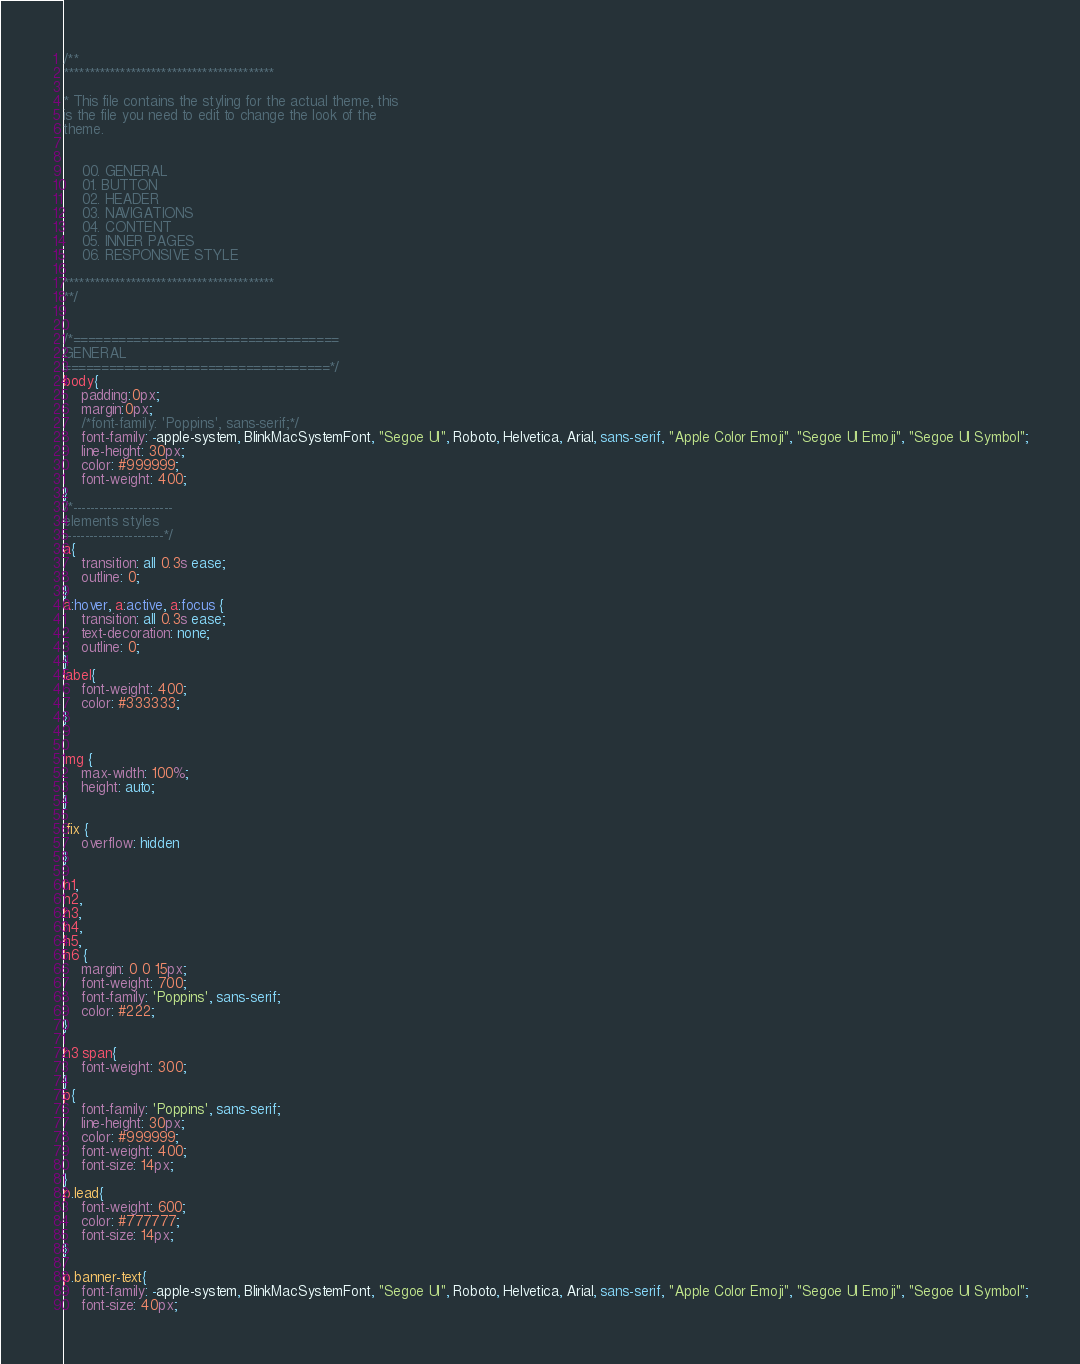Convert code to text. <code><loc_0><loc_0><loc_500><loc_500><_CSS_>/**
*****************************************

* This file contains the styling for the actual theme, this
is the file you need to edit to change the look of the
theme.


    00. GENERAL
    01. BUTTON
    02. HEADER
    03. NAVIGATIONS
    04. CONTENT
    05. INNER PAGES
    06. RESPONSIVE STYLE

*****************************************
**/


/*===================================
GENERAL
===================================*/
body{
    padding:0px; 
    margin:0px;
    /*font-family: 'Poppins', sans-serif;*/
    font-family: -apple-system, BlinkMacSystemFont, "Segoe UI", Roboto, Helvetica, Arial, sans-serif, "Apple Color Emoji", "Segoe UI Emoji", "Segoe UI Symbol";
    line-height: 30px;
    color: #999999;
    font-weight: 400;
}
/*-----------------------
elements styles
-----------------------*/
a{
    transition: all 0.3s ease;
    outline: 0;
}
a:hover, a:active, a:focus {
    transition: all 0.3s ease;
    text-decoration: none;
    outline: 0;
}
label{
    font-weight: 400;
    color: #333333;
}


img {
    max-width: 100%;
    height: auto;
}

.fix {
    overflow: hidden
}

h1,
h2,
h3,
h4,
h5,
h6 {
    margin: 0 0 15px;
    font-weight: 700;
    font-family: 'Poppins', sans-serif;
    color: #222;
}

h3 span{
    font-weight: 300;
}
p{
    font-family: 'Poppins', sans-serif;
    line-height: 30px;
    color: #999999;
    font-weight: 400;
    font-size: 14px;
}
p.lead{
    font-weight: 600;
    color: #777777;
    font-size: 14px;
}

p.banner-text{
    font-family: -apple-system, BlinkMacSystemFont, "Segoe UI", Roboto, Helvetica, Arial, sans-serif, "Apple Color Emoji", "Segoe UI Emoji", "Segoe UI Symbol";
    font-size: 40px;</code> 